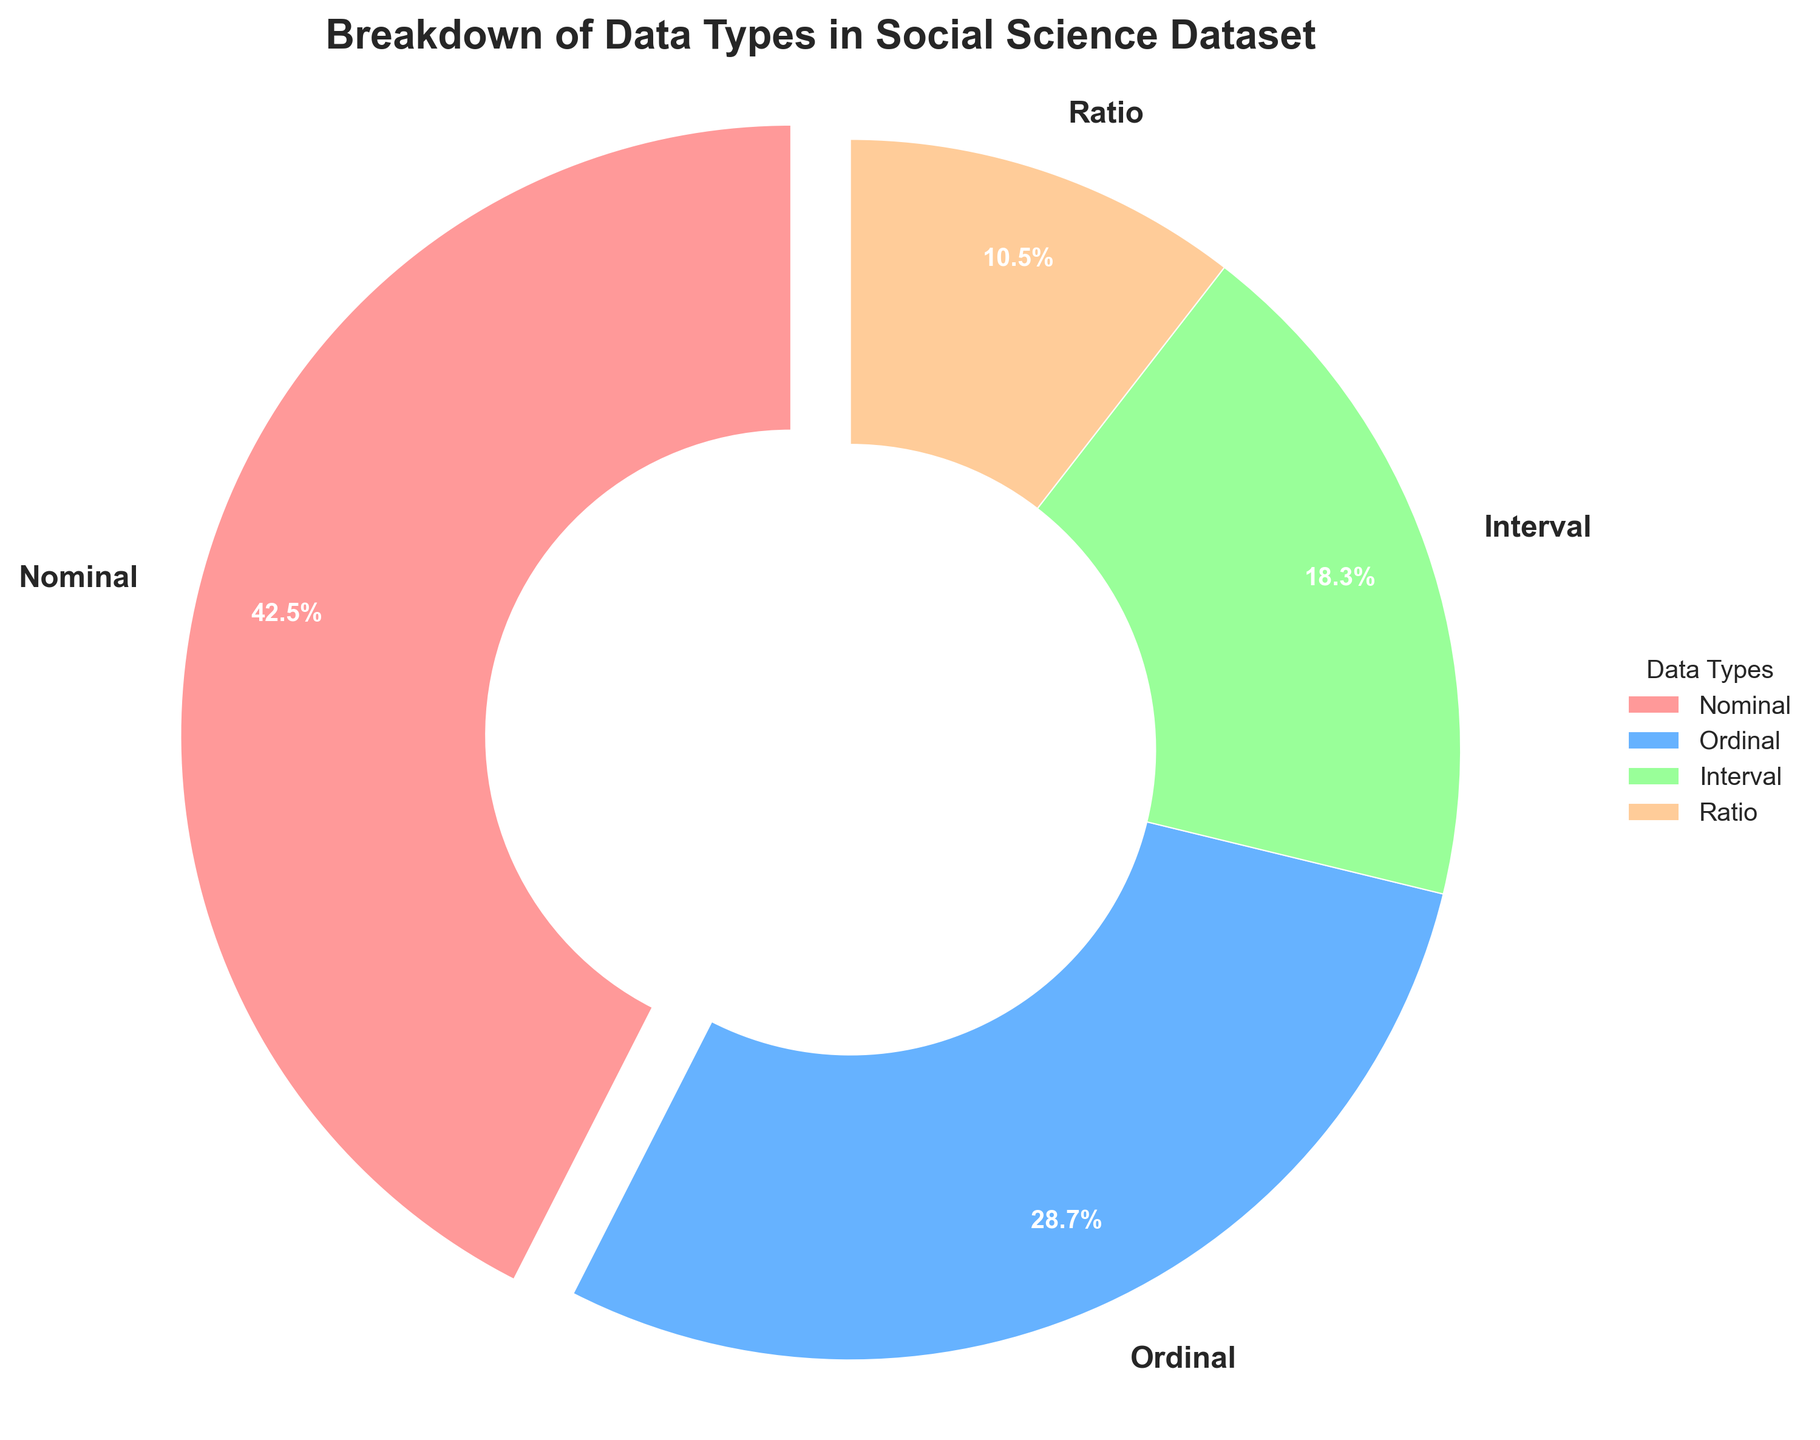What is the most common data type in the dataset? The slice with the largest percentage in the pie chart represents the most common data type. Looking at the pie chart, the largest slice corresponds to the 'Nominal' data type.
Answer: Nominal Which data type occupies the smallest portion of the dataset? The slice with the smallest percentage represents the least common data type. The smallest slice in the pie chart is labeled 'Ratio'.
Answer: Ratio What is the combined percentage of Ordinal and Interval data types? To find the combined percentage, sum the percentages of Ordinal and Interval. From the chart, Ordinal is 28.7% and Interval is 18.3%. Therefore, the combined percentage is 28.7% + 18.3% = 47%.
Answer: 47% Is the percentage of Nominal data type more than double that of the Ratio data type? Compare the percentage of Nominal (42.5%) to twice the percentage of Ratio (2 * 10.5% = 21%). Since 42.5% is indeed greater than 21%, the statement is true.
Answer: Yes How much more percentage does the Nominal data type have compared to the Interval data type? Subtract the percentage of Interval from the percentage of Nominal. Nominal is 42.5% and Interval is 18.3%, so 42.5% - 18.3% = 24.2%.
Answer: 24.2% Which data types have percentages above 20%? The pie chart shows data types with their respective percentages. Nominal (42.5%) and Ordinal (28.7%) are both above 20%.
Answer: Nominal, Ordinal What is the difference in percentage between the second most common and least common data types? The second most common data type is Ordinal at 28.7%, and the least common is Ratio at 10.5%. The difference is 28.7% - 10.5% = 18.2%.
Answer: 18.2% If you group Interval and Ratio data types together, what is their combined percentage? Sum the percentages of Interval and Ratio. Interval is 18.3% and Ratio is 10.5%, so the combined percentage is 18.3% + 10.5% = 28.8%.
Answer: 28.8% What percentage of the dataset is composed of data types other than Nominal? Subtract the percentage of Nominal from 100%. Nominal is 42.5%, so 100% - 42.5% = 57.5%.
Answer: 57.5% How do the visual attributes indicate which slice corresponds to the Nominal data type? The Nominal slice is visually distinct because it is slightly separated from the rest of the pie (exploded), has a label indicating 'Nominal', and occupies a larger area compared to other slices.
Answer: Largest, Exploded 